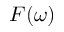<formula> <loc_0><loc_0><loc_500><loc_500>F ( \omega )</formula> 